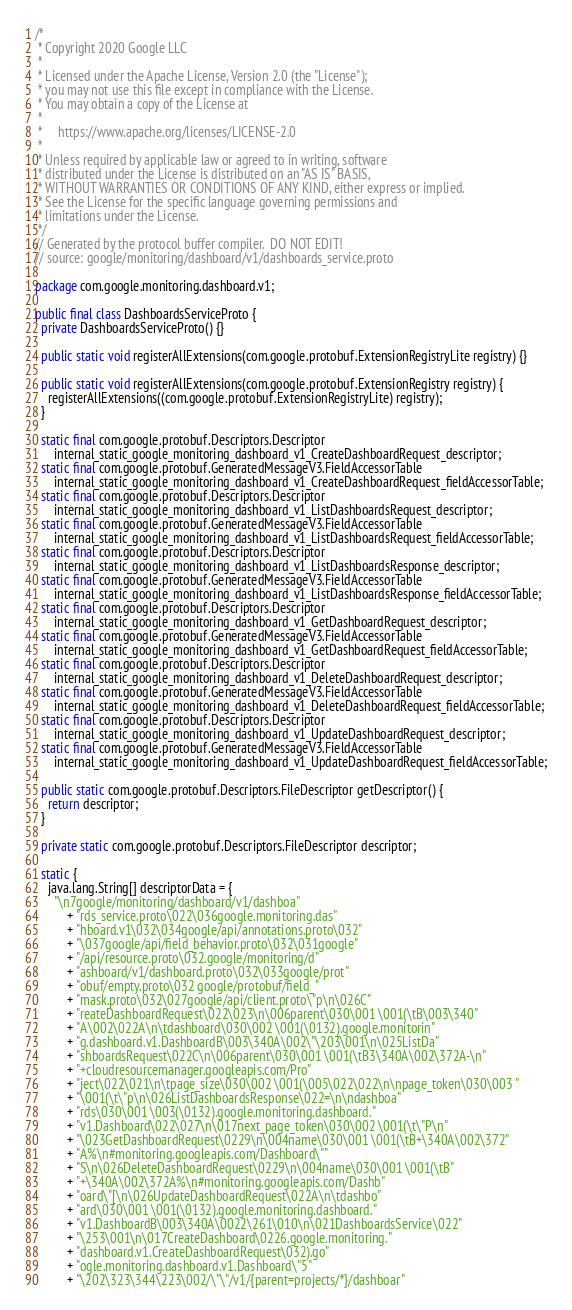Convert code to text. <code><loc_0><loc_0><loc_500><loc_500><_Java_>/*
 * Copyright 2020 Google LLC
 *
 * Licensed under the Apache License, Version 2.0 (the "License");
 * you may not use this file except in compliance with the License.
 * You may obtain a copy of the License at
 *
 *     https://www.apache.org/licenses/LICENSE-2.0
 *
 * Unless required by applicable law or agreed to in writing, software
 * distributed under the License is distributed on an "AS IS" BASIS,
 * WITHOUT WARRANTIES OR CONDITIONS OF ANY KIND, either express or implied.
 * See the License for the specific language governing permissions and
 * limitations under the License.
 */
// Generated by the protocol buffer compiler.  DO NOT EDIT!
// source: google/monitoring/dashboard/v1/dashboards_service.proto

package com.google.monitoring.dashboard.v1;

public final class DashboardsServiceProto {
  private DashboardsServiceProto() {}

  public static void registerAllExtensions(com.google.protobuf.ExtensionRegistryLite registry) {}

  public static void registerAllExtensions(com.google.protobuf.ExtensionRegistry registry) {
    registerAllExtensions((com.google.protobuf.ExtensionRegistryLite) registry);
  }

  static final com.google.protobuf.Descriptors.Descriptor
      internal_static_google_monitoring_dashboard_v1_CreateDashboardRequest_descriptor;
  static final com.google.protobuf.GeneratedMessageV3.FieldAccessorTable
      internal_static_google_monitoring_dashboard_v1_CreateDashboardRequest_fieldAccessorTable;
  static final com.google.protobuf.Descriptors.Descriptor
      internal_static_google_monitoring_dashboard_v1_ListDashboardsRequest_descriptor;
  static final com.google.protobuf.GeneratedMessageV3.FieldAccessorTable
      internal_static_google_monitoring_dashboard_v1_ListDashboardsRequest_fieldAccessorTable;
  static final com.google.protobuf.Descriptors.Descriptor
      internal_static_google_monitoring_dashboard_v1_ListDashboardsResponse_descriptor;
  static final com.google.protobuf.GeneratedMessageV3.FieldAccessorTable
      internal_static_google_monitoring_dashboard_v1_ListDashboardsResponse_fieldAccessorTable;
  static final com.google.protobuf.Descriptors.Descriptor
      internal_static_google_monitoring_dashboard_v1_GetDashboardRequest_descriptor;
  static final com.google.protobuf.GeneratedMessageV3.FieldAccessorTable
      internal_static_google_monitoring_dashboard_v1_GetDashboardRequest_fieldAccessorTable;
  static final com.google.protobuf.Descriptors.Descriptor
      internal_static_google_monitoring_dashboard_v1_DeleteDashboardRequest_descriptor;
  static final com.google.protobuf.GeneratedMessageV3.FieldAccessorTable
      internal_static_google_monitoring_dashboard_v1_DeleteDashboardRequest_fieldAccessorTable;
  static final com.google.protobuf.Descriptors.Descriptor
      internal_static_google_monitoring_dashboard_v1_UpdateDashboardRequest_descriptor;
  static final com.google.protobuf.GeneratedMessageV3.FieldAccessorTable
      internal_static_google_monitoring_dashboard_v1_UpdateDashboardRequest_fieldAccessorTable;

  public static com.google.protobuf.Descriptors.FileDescriptor getDescriptor() {
    return descriptor;
  }

  private static com.google.protobuf.Descriptors.FileDescriptor descriptor;

  static {
    java.lang.String[] descriptorData = {
      "\n7google/monitoring/dashboard/v1/dashboa"
          + "rds_service.proto\022\036google.monitoring.das"
          + "hboard.v1\032\034google/api/annotations.proto\032"
          + "\037google/api/field_behavior.proto\032\031google"
          + "/api/resource.proto\032.google/monitoring/d"
          + "ashboard/v1/dashboard.proto\032\033google/prot"
          + "obuf/empty.proto\032 google/protobuf/field_"
          + "mask.proto\032\027google/api/client.proto\"p\n\026C"
          + "reateDashboardRequest\022\023\n\006parent\030\001 \001(\tB\003\340"
          + "A\002\022A\n\tdashboard\030\002 \001(\0132).google.monitorin"
          + "g.dashboard.v1.DashboardB\003\340A\002\"\203\001\n\025ListDa"
          + "shboardsRequest\022C\n\006parent\030\001 \001(\tB3\340A\002\372A-\n"
          + "+cloudresourcemanager.googleapis.com/Pro"
          + "ject\022\021\n\tpage_size\030\002 \001(\005\022\022\n\npage_token\030\003 "
          + "\001(\t\"p\n\026ListDashboardsResponse\022=\n\ndashboa"
          + "rds\030\001 \003(\0132).google.monitoring.dashboard."
          + "v1.Dashboard\022\027\n\017next_page_token\030\002 \001(\t\"P\n"
          + "\023GetDashboardRequest\0229\n\004name\030\001 \001(\tB+\340A\002\372"
          + "A%\n#monitoring.googleapis.com/Dashboard\""
          + "S\n\026DeleteDashboardRequest\0229\n\004name\030\001 \001(\tB"
          + "+\340A\002\372A%\n#monitoring.googleapis.com/Dashb"
          + "oard\"[\n\026UpdateDashboardRequest\022A\n\tdashbo"
          + "ard\030\001 \001(\0132).google.monitoring.dashboard."
          + "v1.DashboardB\003\340A\0022\261\010\n\021DashboardsService\022"
          + "\253\001\n\017CreateDashboard\0226.google.monitoring."
          + "dashboard.v1.CreateDashboardRequest\032).go"
          + "ogle.monitoring.dashboard.v1.Dashboard\"5"
          + "\202\323\344\223\002/\"\"/v1/{parent=projects/*}/dashboar"</code> 